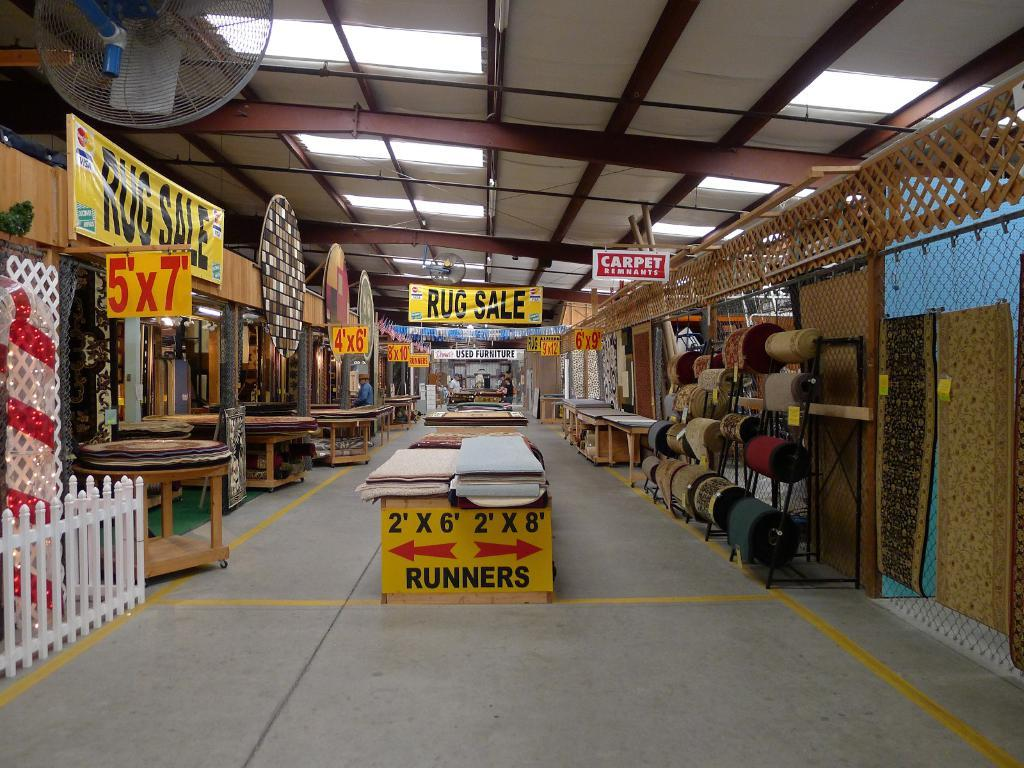Provide a one-sentence caption for the provided image. A sign at the front of an aisle explains where runners are at. 